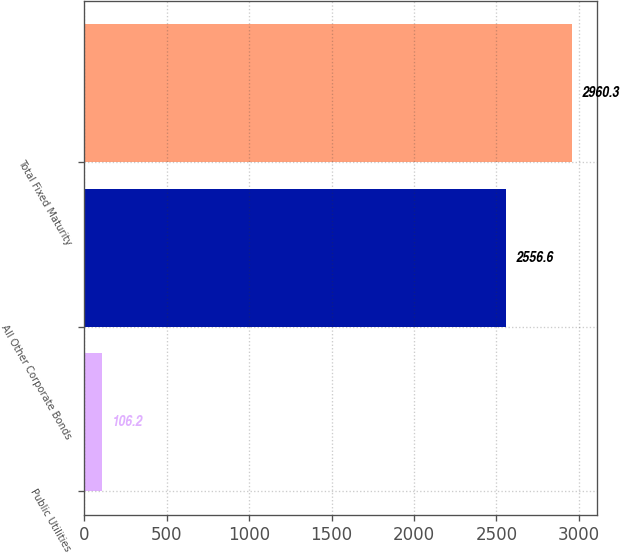Convert chart. <chart><loc_0><loc_0><loc_500><loc_500><bar_chart><fcel>Public Utilities<fcel>All Other Corporate Bonds<fcel>Total Fixed Maturity<nl><fcel>106.2<fcel>2556.6<fcel>2960.3<nl></chart> 